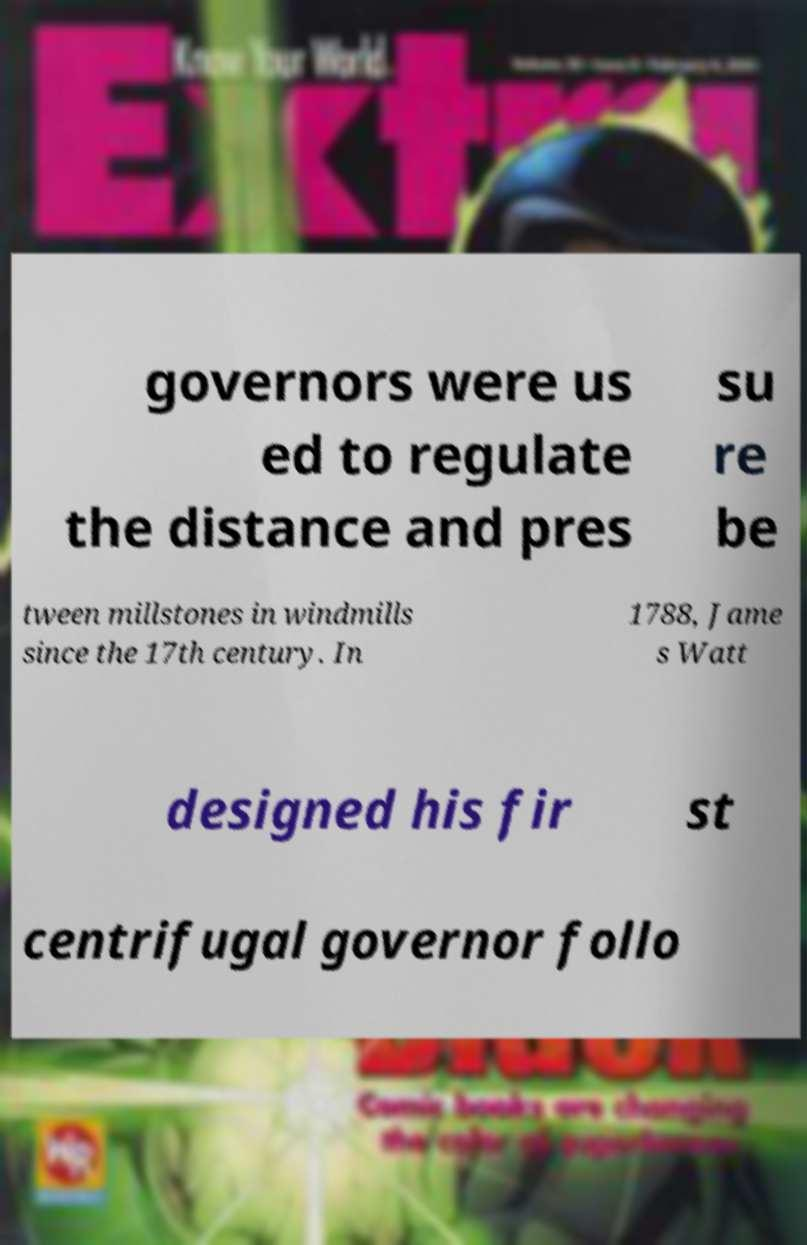Could you assist in decoding the text presented in this image and type it out clearly? governors were us ed to regulate the distance and pres su re be tween millstones in windmills since the 17th century. In 1788, Jame s Watt designed his fir st centrifugal governor follo 